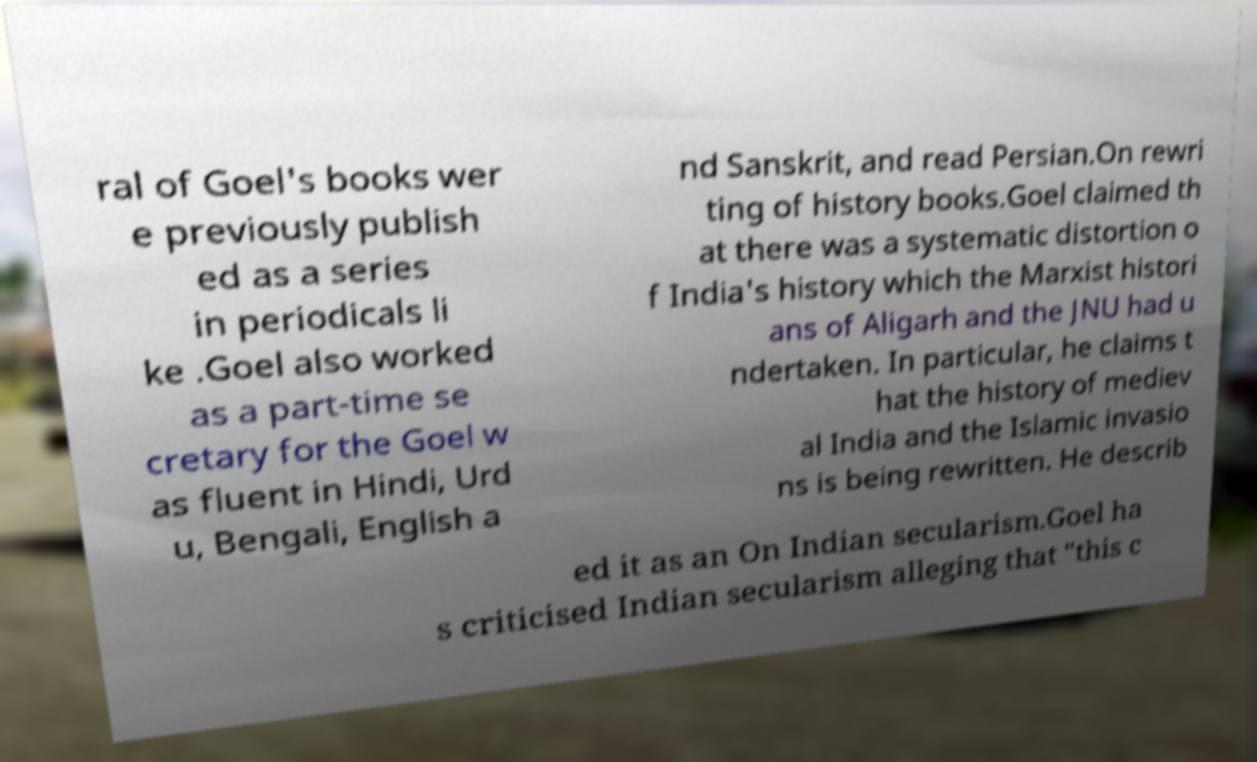There's text embedded in this image that I need extracted. Can you transcribe it verbatim? ral of Goel's books wer e previously publish ed as a series in periodicals li ke .Goel also worked as a part-time se cretary for the Goel w as fluent in Hindi, Urd u, Bengali, English a nd Sanskrit, and read Persian.On rewri ting of history books.Goel claimed th at there was a systematic distortion o f India's history which the Marxist histori ans of Aligarh and the JNU had u ndertaken. In particular, he claims t hat the history of mediev al India and the Islamic invasio ns is being rewritten. He describ ed it as an On Indian secularism.Goel ha s criticised Indian secularism alleging that "this c 